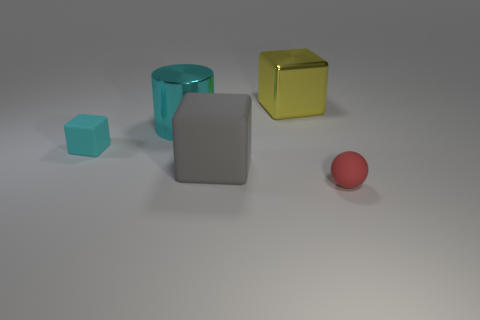Subtract all small blocks. How many blocks are left? 2 Subtract 1 cubes. How many cubes are left? 2 Subtract all small rubber spheres. Subtract all large objects. How many objects are left? 1 Add 1 big rubber things. How many big rubber things are left? 2 Add 5 gray rubber things. How many gray rubber things exist? 6 Add 1 small brown matte cylinders. How many objects exist? 6 Subtract all cyan cubes. How many cubes are left? 2 Subtract 0 blue cylinders. How many objects are left? 5 Subtract all balls. How many objects are left? 4 Subtract all purple spheres. Subtract all yellow cylinders. How many spheres are left? 1 